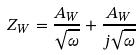<formula> <loc_0><loc_0><loc_500><loc_500>Z _ { W } = \frac { A _ { W } } { \sqrt { \omega } } + \frac { A _ { W } } { j \sqrt { \omega } }</formula> 